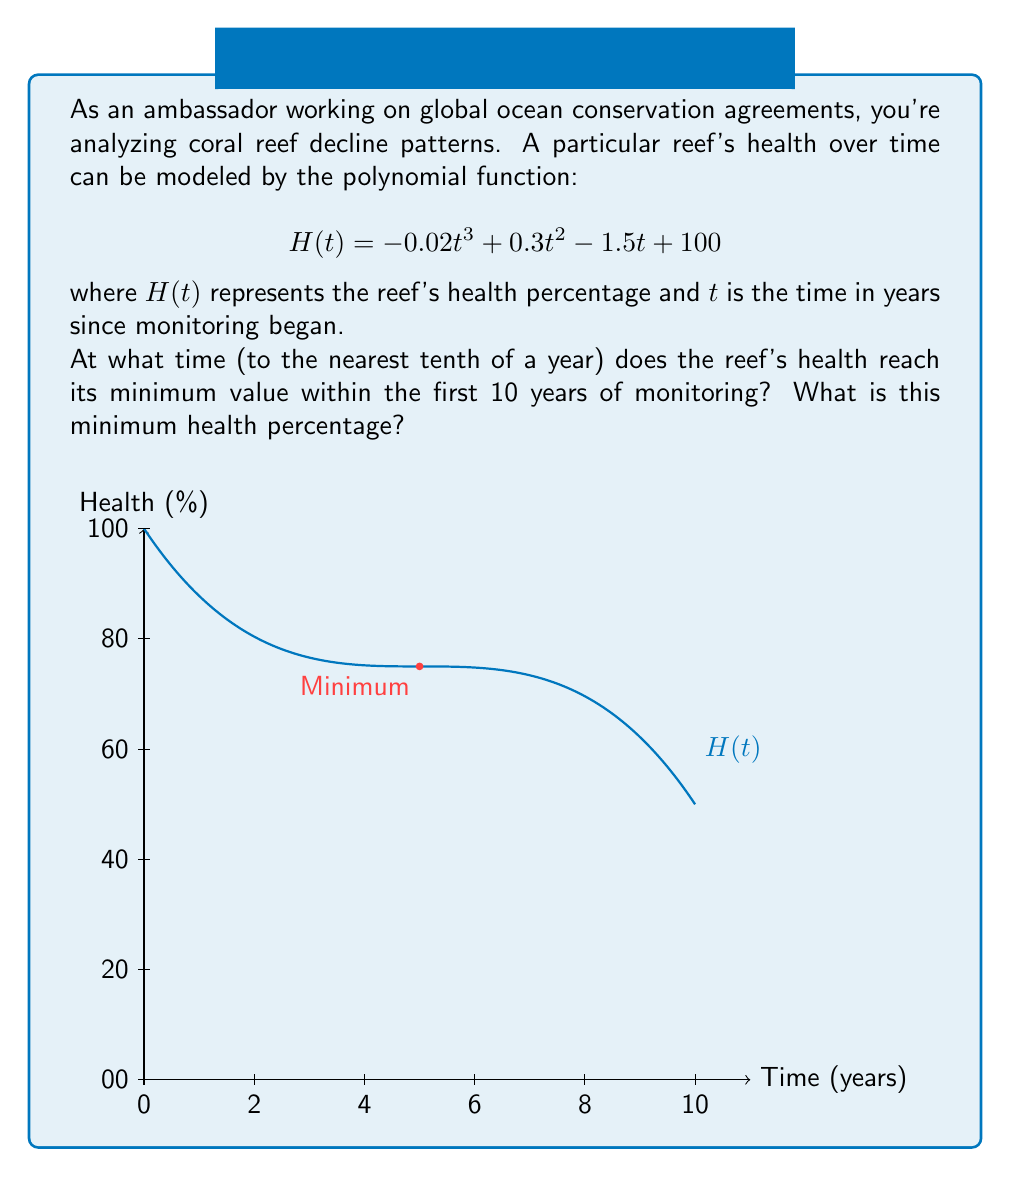Can you solve this math problem? To find the minimum value of the function within the first 10 years, we need to follow these steps:

1) First, find the derivative of $H(t)$:
   $$H'(t) = -0.06t^2 + 0.6t - 1.5$$

2) Set $H'(t) = 0$ to find critical points:
   $$-0.06t^2 + 0.6t - 1.5 = 0$$

3) Solve this quadratic equation:
   $$t = \frac{-0.6 \pm \sqrt{0.6^2 - 4(-0.06)(-1.5)}}{2(-0.06)}$$
   $$t = \frac{-0.6 \pm \sqrt{0.36 + 0.36}}{-0.12} = \frac{-0.6 \pm \sqrt{0.72}}{-0.12}$$
   $$t \approx 5.0 \text{ or } 5.0$$ (both roots are approximately 5)

4) The critical point $t = 5$ is within our domain of interest (0 to 10 years).

5) To confirm it's a minimum, check the second derivative:
   $$H''(t) = -0.12t + 0.6$$
   $$H''(5) = -0.12(5) + 0.6 = 0 > 0$$
   This confirms that $t = 5$ is a local minimum.

6) Calculate the health percentage at $t = 5$:
   $$H(5) = -0.02(5^3) + 0.3(5^2) - 1.5(5) + 100$$
   $$= -2.5 + 7.5 - 7.5 + 100 = 97.5\%$$

Therefore, the reef's health reaches its minimum value after 5.0 years, and the minimum health percentage is 97.5%.
Answer: 5.0 years; 97.5% 